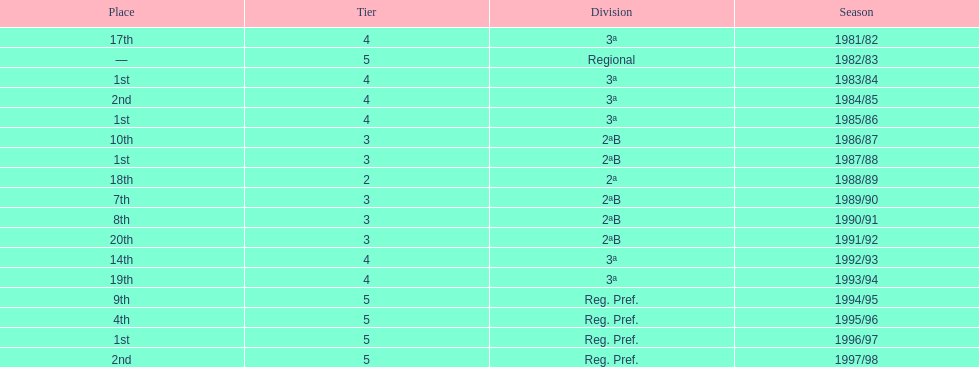Which season(s) earned first place? 1983/84, 1985/86, 1987/88, 1996/97. Give me the full table as a dictionary. {'header': ['Place', 'Tier', 'Division', 'Season'], 'rows': [['17th', '4', '3ª', '1981/82'], ['—', '5', 'Regional', '1982/83'], ['1st', '4', '3ª', '1983/84'], ['2nd', '4', '3ª', '1984/85'], ['1st', '4', '3ª', '1985/86'], ['10th', '3', '2ªB', '1986/87'], ['1st', '3', '2ªB', '1987/88'], ['18th', '2', '2ª', '1988/89'], ['7th', '3', '2ªB', '1989/90'], ['8th', '3', '2ªB', '1990/91'], ['20th', '3', '2ªB', '1991/92'], ['14th', '4', '3ª', '1992/93'], ['19th', '4', '3ª', '1993/94'], ['9th', '5', 'Reg. Pref.', '1994/95'], ['4th', '5', 'Reg. Pref.', '1995/96'], ['1st', '5', 'Reg. Pref.', '1996/97'], ['2nd', '5', 'Reg. Pref.', '1997/98']]} 